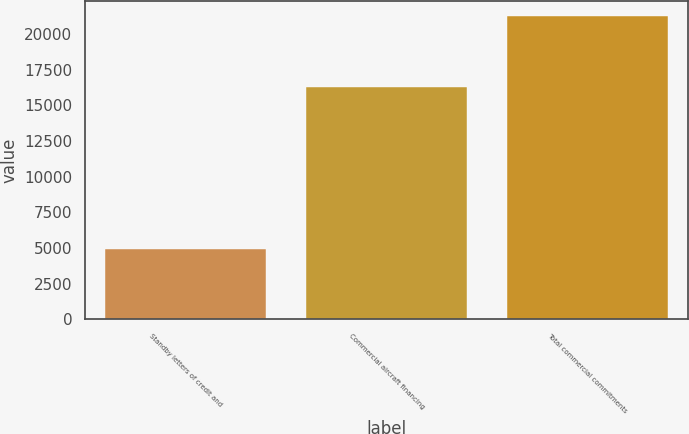Convert chart. <chart><loc_0><loc_0><loc_500><loc_500><bar_chart><fcel>Standby letters of credit and<fcel>Commercial aircraft financing<fcel>Total commercial commitments<nl><fcel>4968<fcel>16283<fcel>21251<nl></chart> 